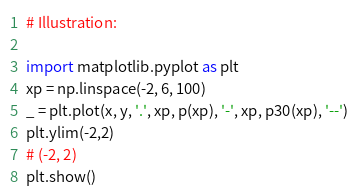<code> <loc_0><loc_0><loc_500><loc_500><_Python_># Illustration:

import matplotlib.pyplot as plt
xp = np.linspace(-2, 6, 100)
_ = plt.plot(x, y, '.', xp, p(xp), '-', xp, p30(xp), '--')
plt.ylim(-2,2)
# (-2, 2)
plt.show()
</code> 